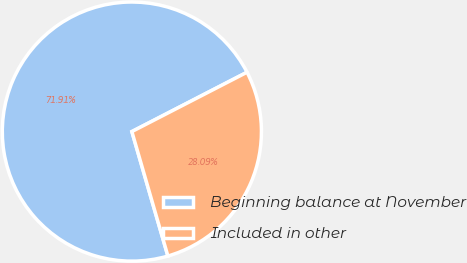<chart> <loc_0><loc_0><loc_500><loc_500><pie_chart><fcel>Beginning balance at November<fcel>Included in other<nl><fcel>71.91%<fcel>28.09%<nl></chart> 